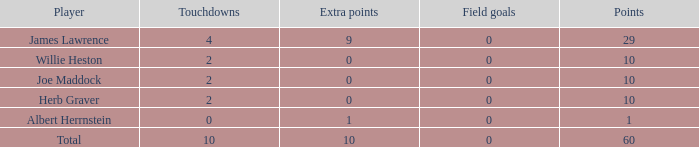What is the average number of points for players with 4 touchdowns and more than 0 field goals? None. 